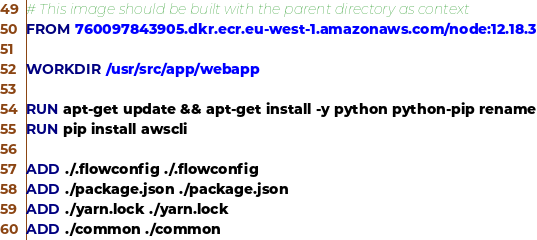Convert code to text. <code><loc_0><loc_0><loc_500><loc_500><_Dockerfile_># This image should be built with the parent directory as context
FROM 760097843905.dkr.ecr.eu-west-1.amazonaws.com/node:12.18.3

WORKDIR /usr/src/app/webapp

RUN apt-get update && apt-get install -y python python-pip rename
RUN pip install awscli

ADD ./.flowconfig ./.flowconfig
ADD ./package.json ./package.json
ADD ./yarn.lock ./yarn.lock
ADD ./common ./common</code> 